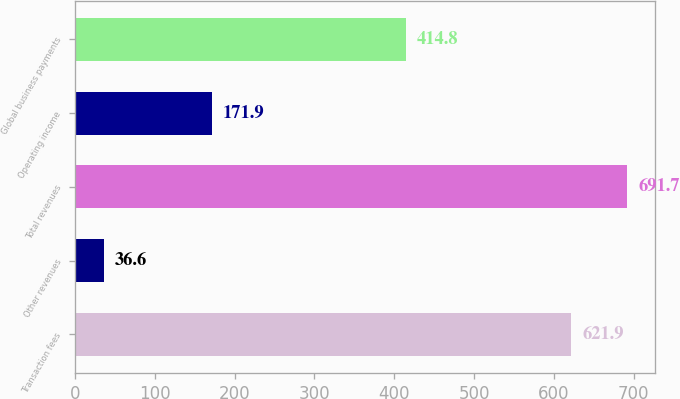Convert chart. <chart><loc_0><loc_0><loc_500><loc_500><bar_chart><fcel>Transaction fees<fcel>Other revenues<fcel>Total revenues<fcel>Operating income<fcel>Global business payments<nl><fcel>621.9<fcel>36.6<fcel>691.7<fcel>171.9<fcel>414.8<nl></chart> 